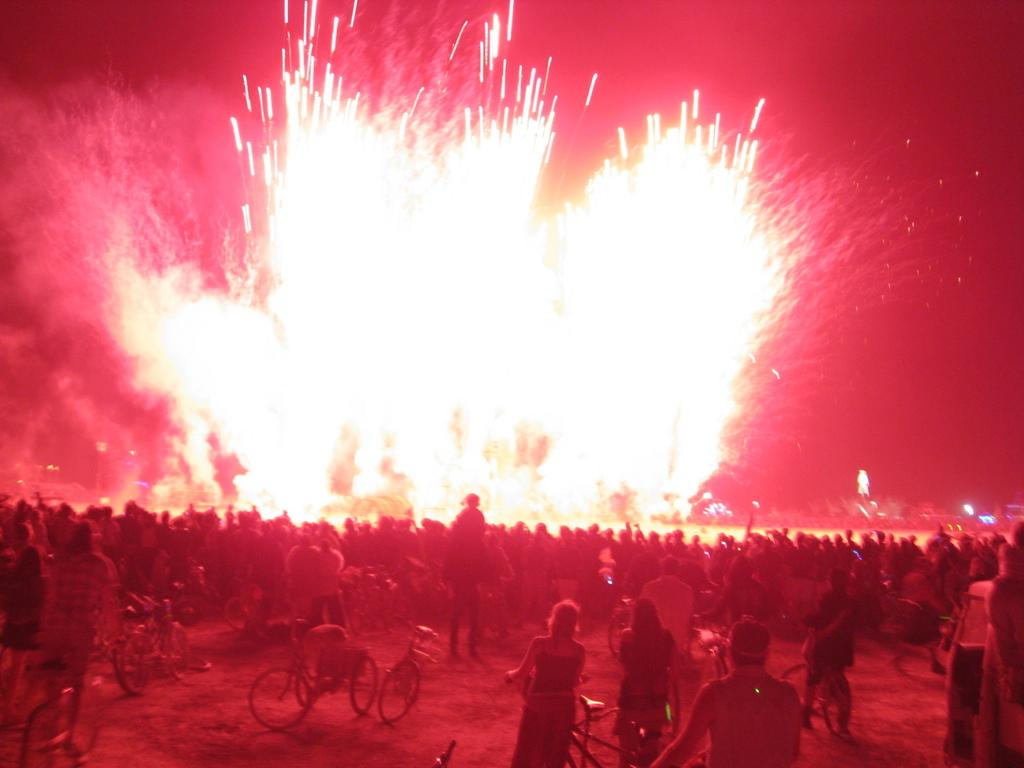How many people are in the image? There is a group of people in the image, but the exact number is not specified. What are the people doing in the image? Some persons are standing on the ground, while others are riding bicycles. What can be seen in the background of the image? There are lights and the sky visible in the background. What is the price of the dust that can be seen in the image? There is no dust present in the image, and therefore no price can be determined. 